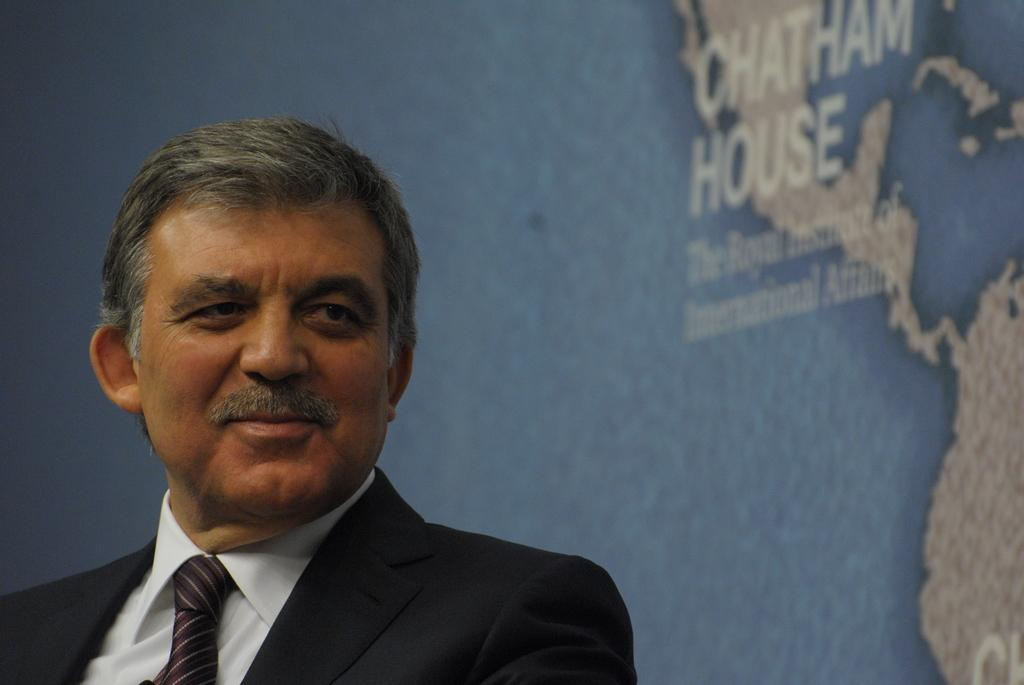Who is present in the image? There is a person in the image. What is the person wearing? The person is wearing a suit. What can be seen on the screen in the image? Unfortunately, we cannot determine what is on the screen from the given facts. What type of church can be seen in the background of the image? There is no church present in the image. How many steps are visible leading up to the church in the image? There is no church or steps present in the image. 